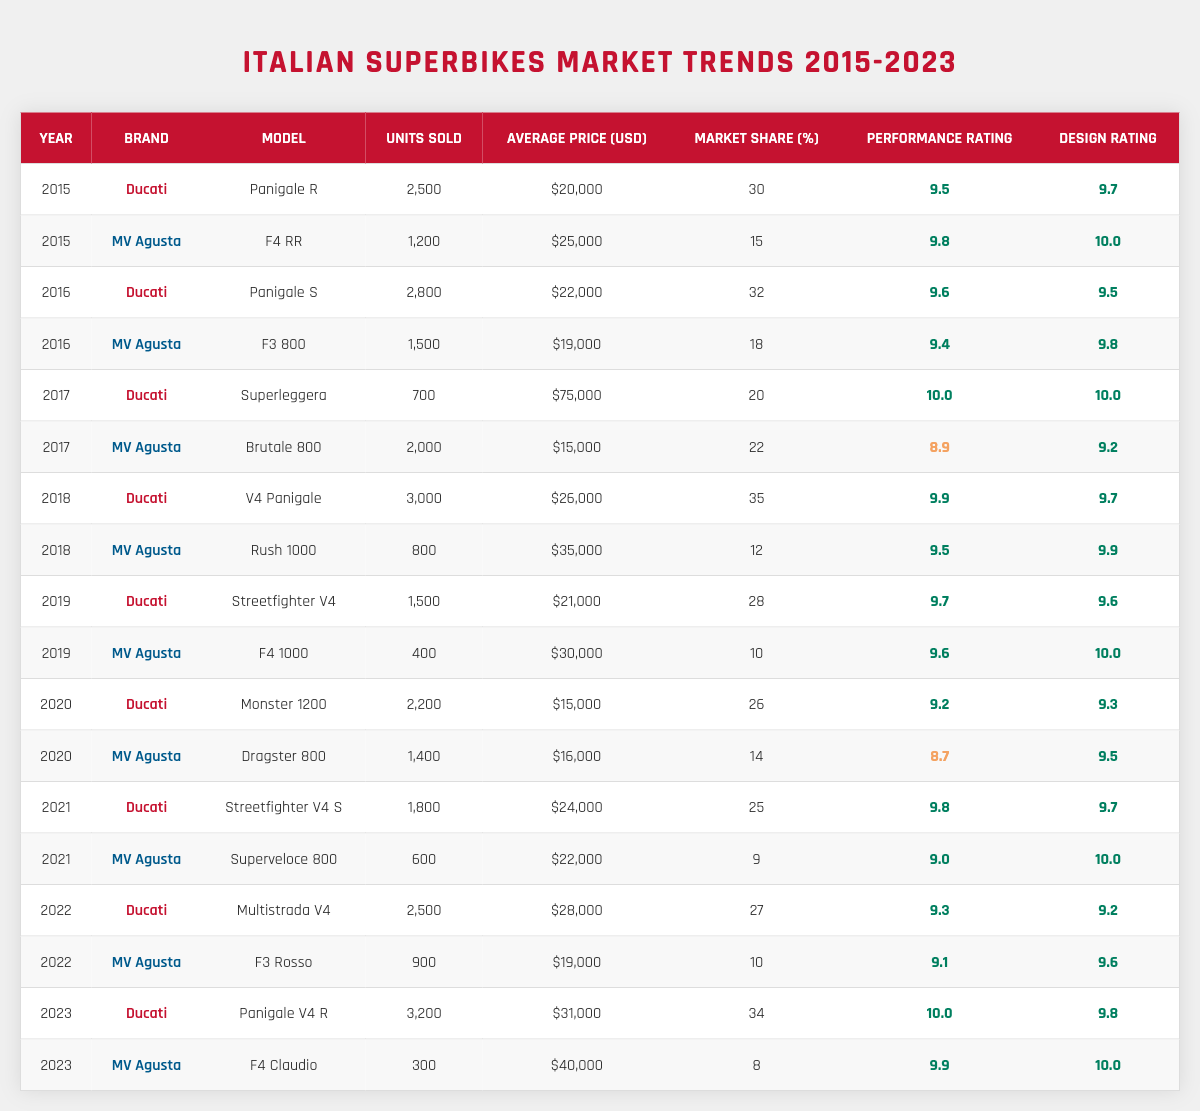What was the total number of units sold by MV Agusta in 2018? To find the total units sold by MV Agusta in 2018, we only need to refer to that specific year. According to the data, MV Agusta sold 800 units of the Rush 1000 in 2018.
Answer: 800 Which Ducati model had the highest average price in 2017? Looking at the table, we see that the Ducati Superleggera had the highest average price for that year at $75,000.
Answer: $75,000 What is the average performance rating of all models from Ducati across the years? To calculate the average, we need to sum the performance ratings for all Ducati models: (9.5 + 9.6 + 10.0 + 9.9 + 9.7 + 9.2 + 9.8 + 9.3 + 10.0) = 69.0. There are 9 models, so the average is 69.0/9 = 7.67.
Answer: 7.67 Did MV Agusta's market share increase from 2019 to 2023? In 2019, MV Agusta had a market share of 10%, and in 2023 it was recorded at 8%. This shows a decrease in market share over these years.
Answer: No What was the total amount of units sold by Ducati from 2020 to 2022? We sum the units sold by Ducati in those years: 2200 (2020) + 1800 (2021) + 2500 (2022) = 6500.
Answer: 6500 Which model had the highest performance rating in 2023? Looking at the table for 2023, the Ducati Panigale V4 R has a performance rating of 10.0, which is the highest.
Answer: Ducati Panigale V4 R How does the average price of MV Agusta models compare to Ducati models in 2021? For MV Agusta in 2021, the average price is ($22,000 + $22,000) / 2 = $22,000. For Ducati, it is ($24,000) / 1 = $24,000. Hence, MV Agusta's average price is lower.
Answer: MV Agusta is lower What was the market share percentage of Ducati in 2018? In 2018, Ducati's market share was 35%. We can directly find this in the table.
Answer: 35% Which brand had a model with a design rating of 10.0 in 2021? In 2021, the MV Agusta Superveloce 800 had a design rating of 10.0, which is the only instance for that year among the two brands.
Answer: MV Agusta What are the units sold by Ducati in the year with the maximum units sold for them? The highest number of units sold by Ducati was 3,200 units in 2023 as seen in the table.
Answer: 3200 In which year did the Ducati brand have a performance rating below 9.0? The Ducati brand never had a performance rating below 9.0 in any of the years listed in the table.
Answer: No year 